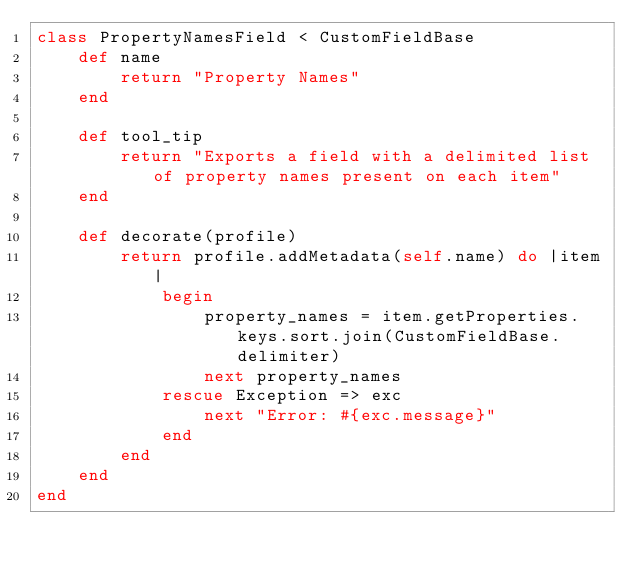Convert code to text. <code><loc_0><loc_0><loc_500><loc_500><_Ruby_>class PropertyNamesField < CustomFieldBase
	def name
		return "Property Names"
	end

	def tool_tip
		return "Exports a field with a delimited list of property names present on each item"
	end

	def decorate(profile)
		return profile.addMetadata(self.name) do |item|
			begin
				property_names = item.getProperties.keys.sort.join(CustomFieldBase.delimiter)
				next property_names
			rescue Exception => exc
				next "Error: #{exc.message}"
			end
		end
	end
end</code> 